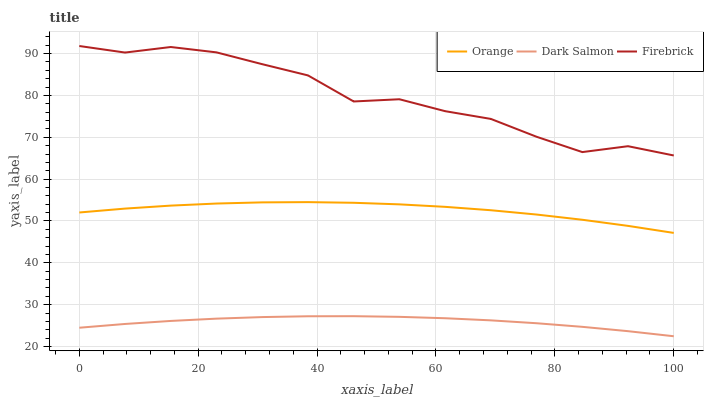Does Dark Salmon have the minimum area under the curve?
Answer yes or no. Yes. Does Firebrick have the maximum area under the curve?
Answer yes or no. Yes. Does Firebrick have the minimum area under the curve?
Answer yes or no. No. Does Dark Salmon have the maximum area under the curve?
Answer yes or no. No. Is Dark Salmon the smoothest?
Answer yes or no. Yes. Is Firebrick the roughest?
Answer yes or no. Yes. Is Firebrick the smoothest?
Answer yes or no. No. Is Dark Salmon the roughest?
Answer yes or no. No. Does Dark Salmon have the lowest value?
Answer yes or no. Yes. Does Firebrick have the lowest value?
Answer yes or no. No. Does Firebrick have the highest value?
Answer yes or no. Yes. Does Dark Salmon have the highest value?
Answer yes or no. No. Is Dark Salmon less than Orange?
Answer yes or no. Yes. Is Firebrick greater than Orange?
Answer yes or no. Yes. Does Dark Salmon intersect Orange?
Answer yes or no. No. 